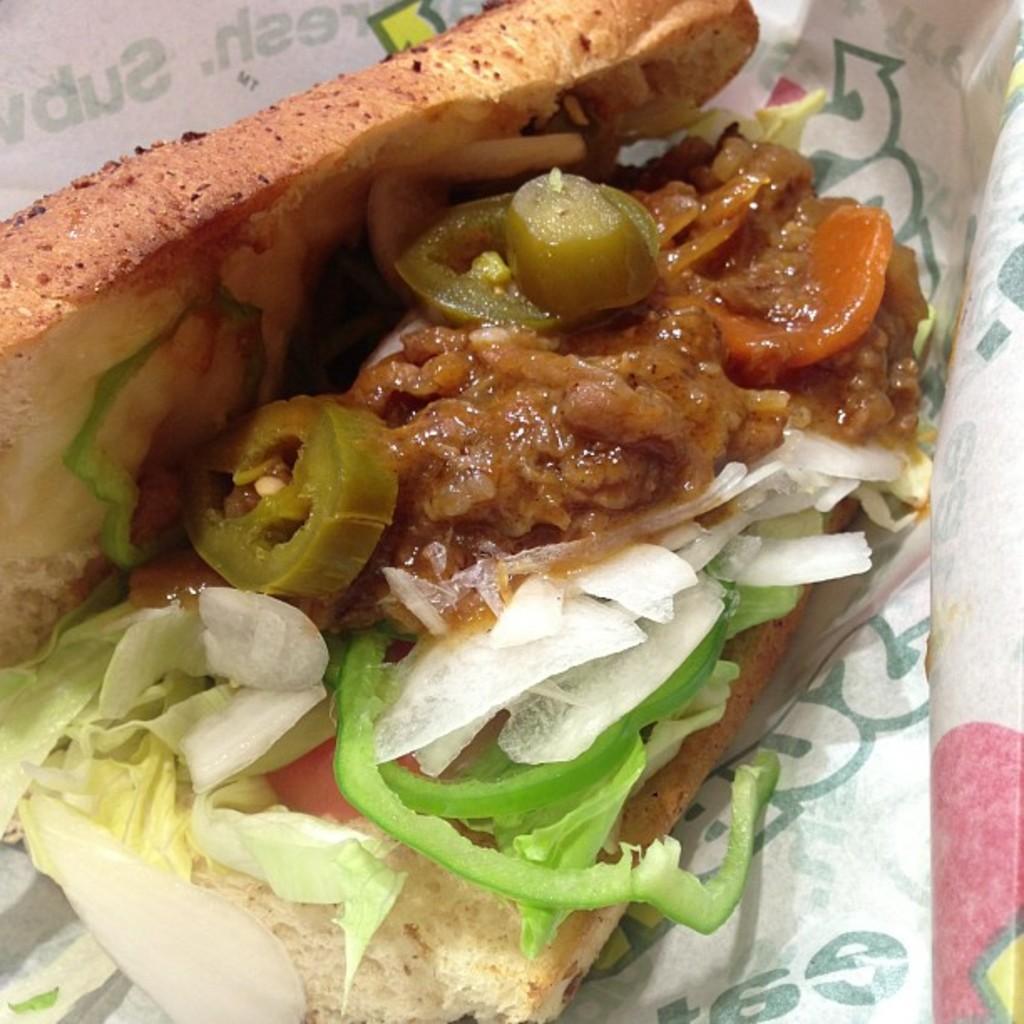Please provide a concise description of this image. In this image I can see food in the centre and around it I can see a white colour paper. On this paper I can see something is written. 